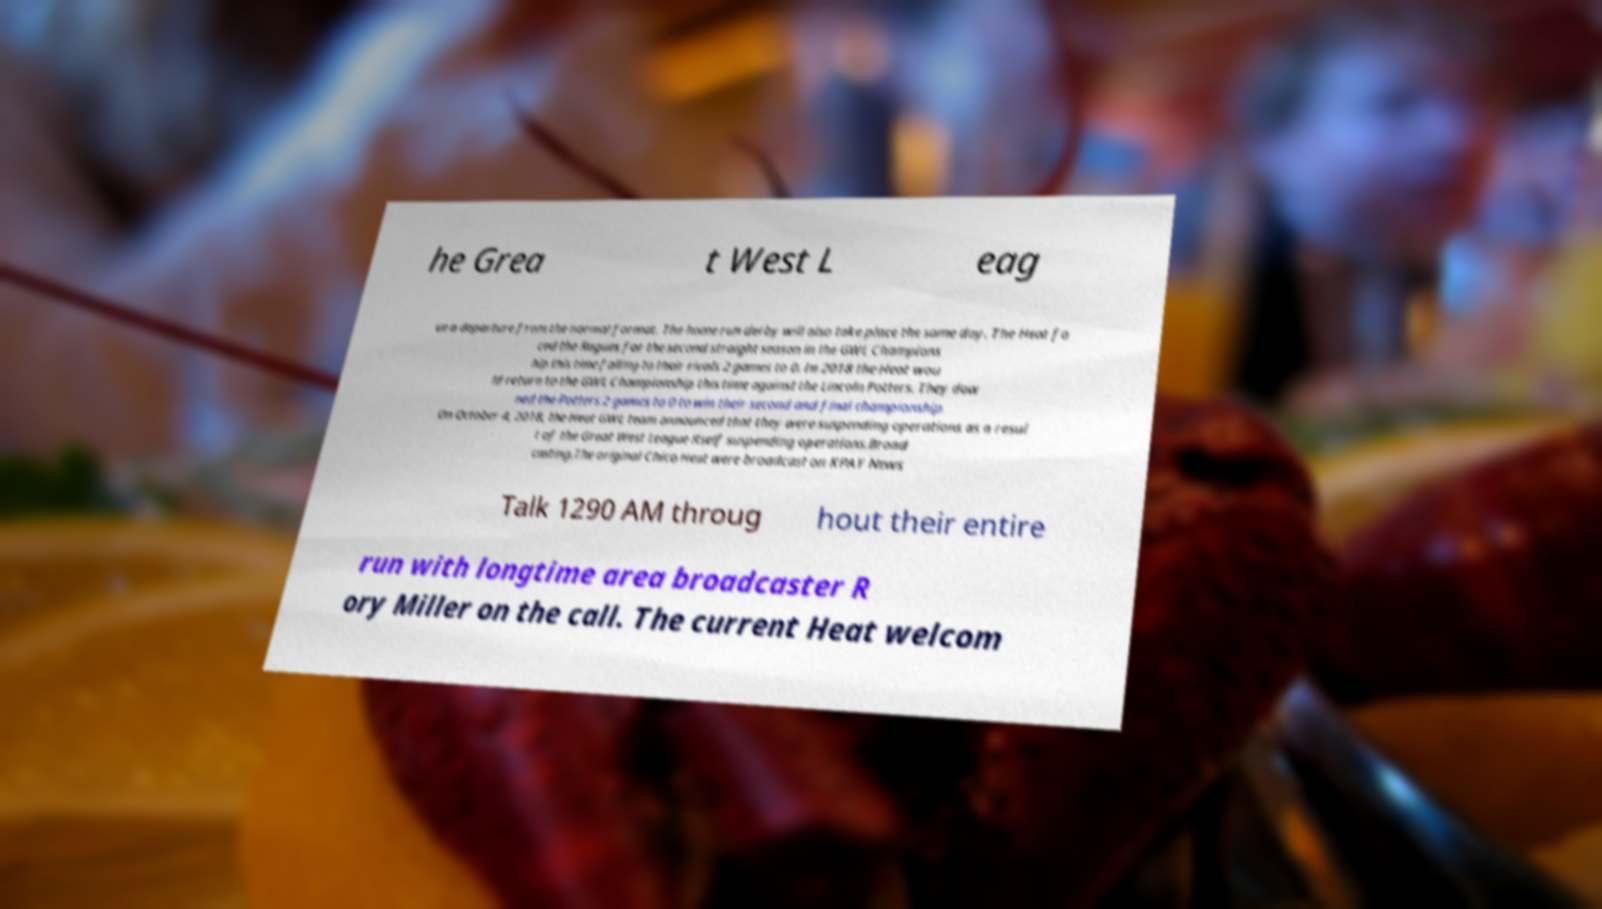Can you accurately transcribe the text from the provided image for me? he Grea t West L eag ue a departure from the normal format. The home run derby will also take place the same day. The Heat fa ced the Rogues for the second straight season in the GWL Champions hip this time falling to their rivals 2 games to 0. In 2018 the Heat wou ld return to the GWL Championship this time against the Lincoln Potters. They dow ned the Potters 2 games to 0 to win their second and final championship. On October 4, 2018, the Heat GWL team announced that they were suspending operations as a resul t of the Great West League itself suspending operations.Broad casting.The original Chico Heat were broadcast on KPAY News Talk 1290 AM throug hout their entire run with longtime area broadcaster R ory Miller on the call. The current Heat welcom 